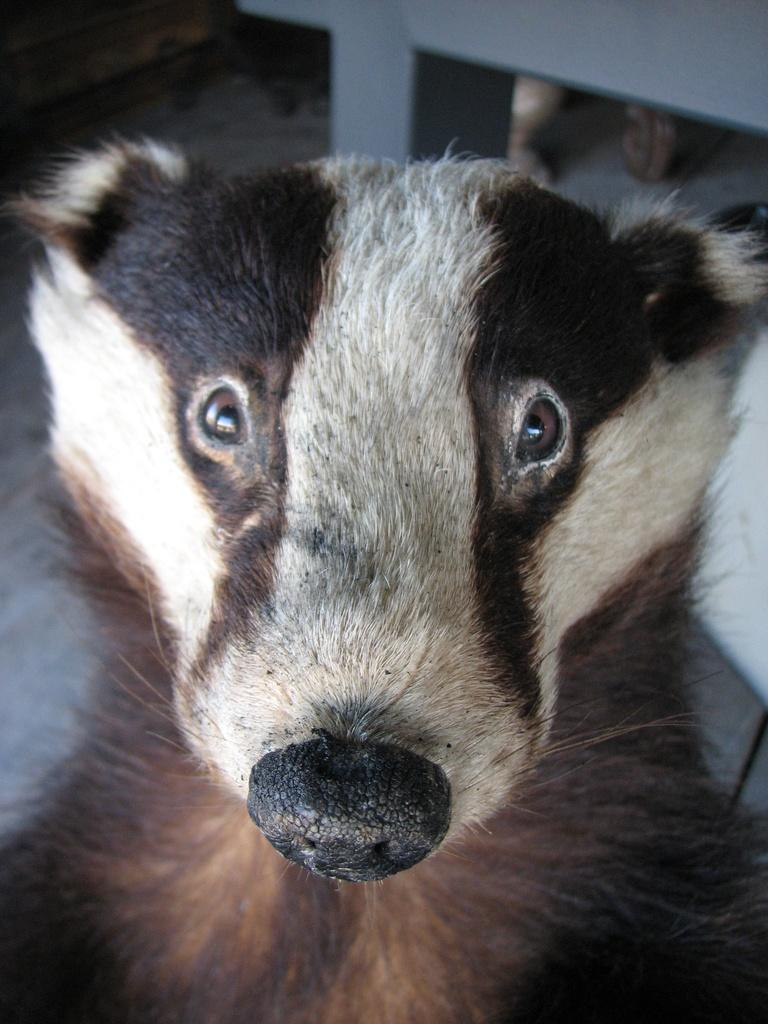What type of animal is in the image? There is an animal in the image, but the specific type cannot be determined from the provided facts. Can you describe the coloring of the animal? The animal has brown and cream coloring. What can be seen in the background of the image? There are objects in the background of the image. What color are the objects in the background? The objects in the background have a gray color. Is the animal wearing a collar in the image? There is no mention of a collar in the provided facts, so it cannot be determined if the animal is wearing one. Does the image show the animal receiving approval from someone? There is no indication of approval or any human interaction in the image, as the facts only mention the animal and its coloring, as well as the objects in the background. 